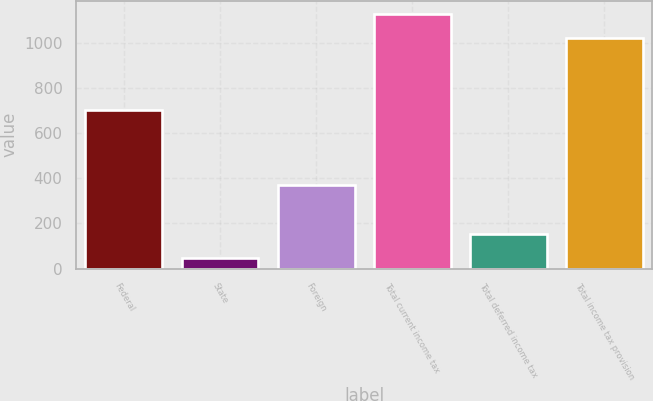Convert chart to OTSL. <chart><loc_0><loc_0><loc_500><loc_500><bar_chart><fcel>Federal<fcel>State<fcel>Foreign<fcel>Total current income tax<fcel>Total deferred income tax<fcel>Total income tax provision<nl><fcel>700<fcel>48<fcel>371<fcel>1129.1<fcel>155.1<fcel>1022<nl></chart> 